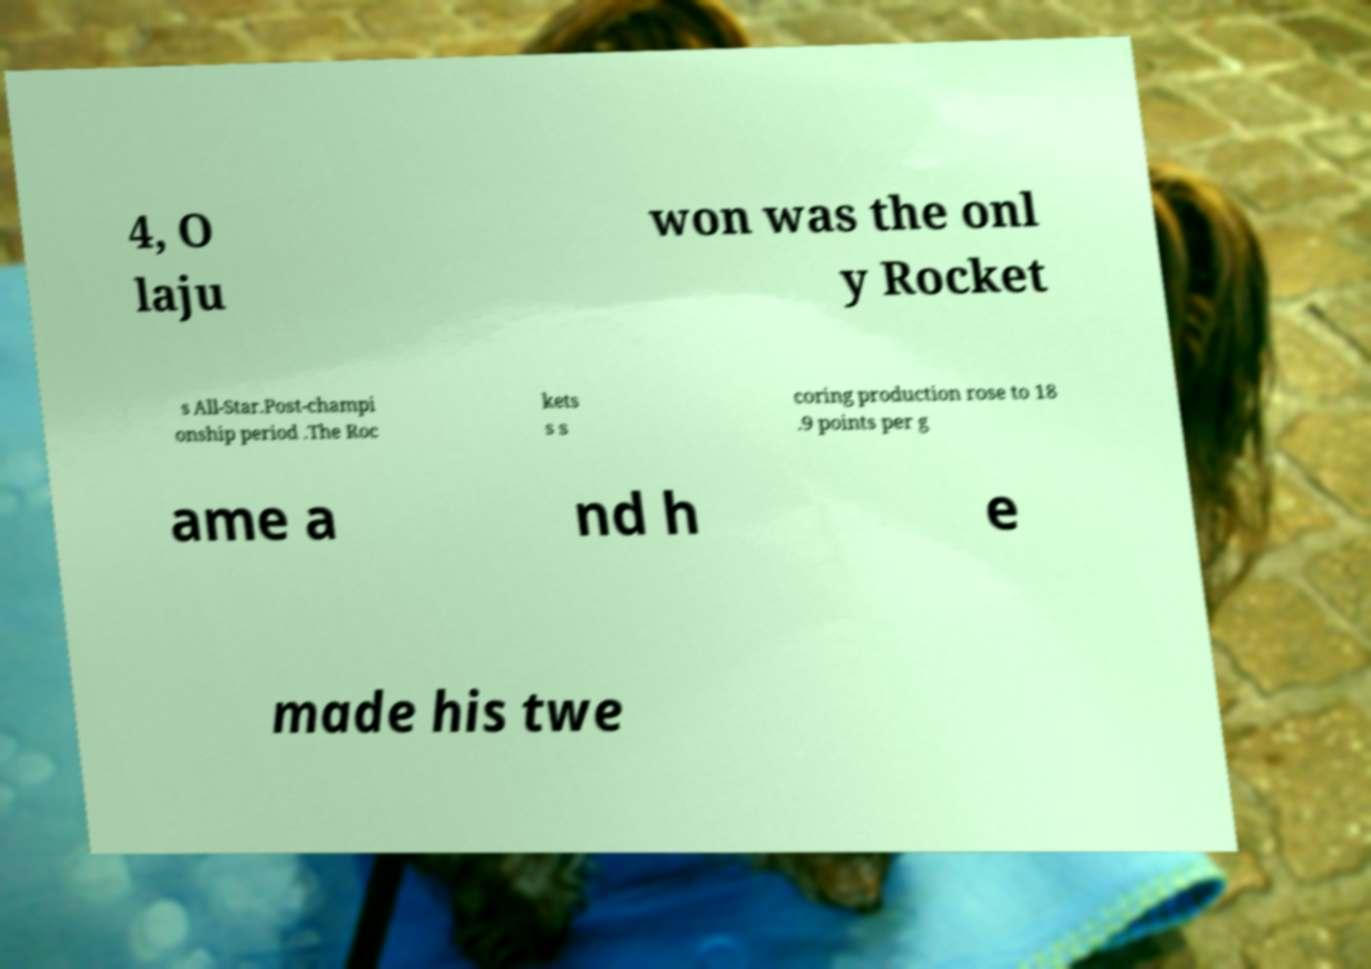Please identify and transcribe the text found in this image. 4, O laju won was the onl y Rocket s All-Star.Post-champi onship period .The Roc kets s s coring production rose to 18 .9 points per g ame a nd h e made his twe 